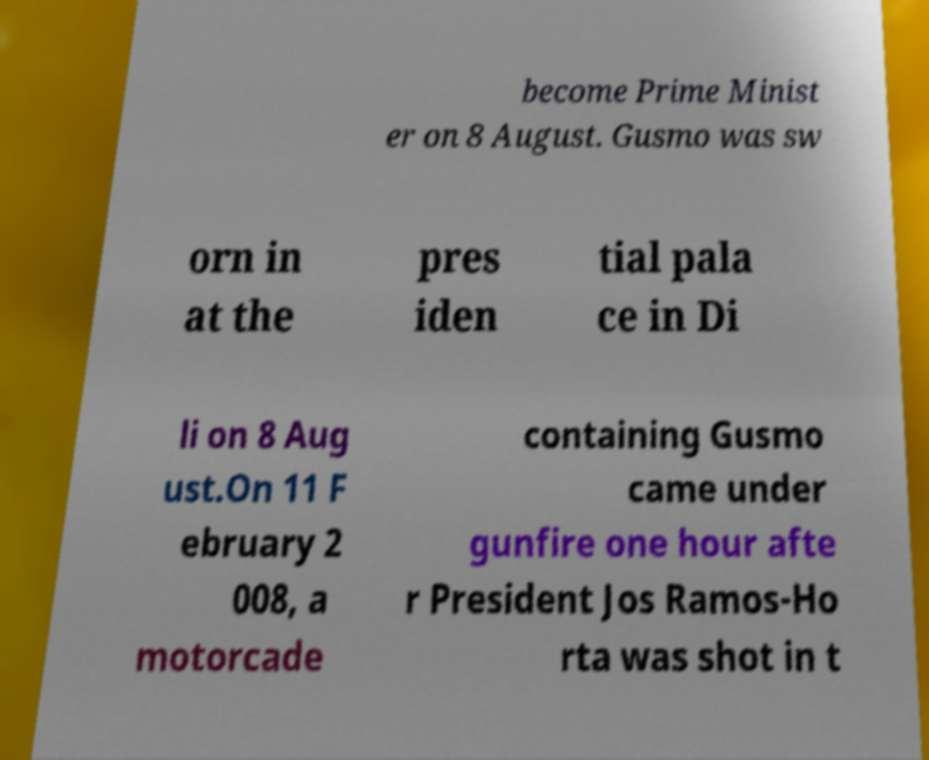For documentation purposes, I need the text within this image transcribed. Could you provide that? become Prime Minist er on 8 August. Gusmo was sw orn in at the pres iden tial pala ce in Di li on 8 Aug ust.On 11 F ebruary 2 008, a motorcade containing Gusmo came under gunfire one hour afte r President Jos Ramos-Ho rta was shot in t 